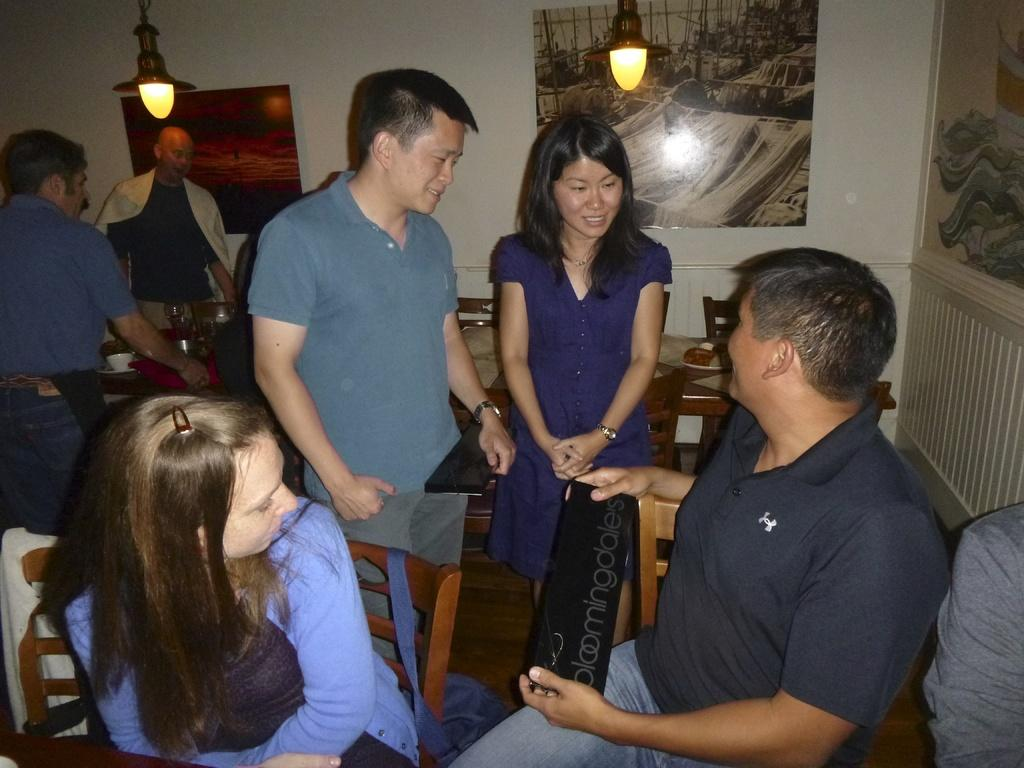How many people are in the image? There is a group of people in the image, but the exact number is not specified. What are the people in the image doing? Some people are seated, while others are standing. What can be seen in the background of the image? There are lights visible in the image, and there are wall paintings on the wall. What type of gold hobbies do the people in the image enjoy? There is no mention of gold or hobbies in the image, so it is not possible to answer that question. 